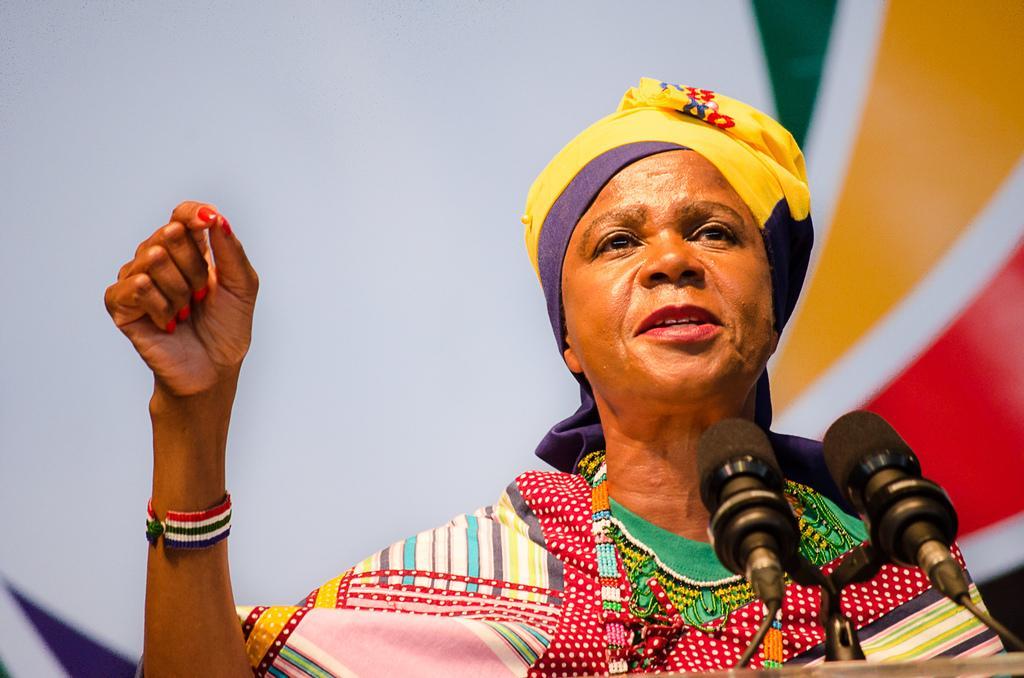Can you describe this image briefly? In the image there is a person and the person is speaking something, there are two mics in front of the person. 